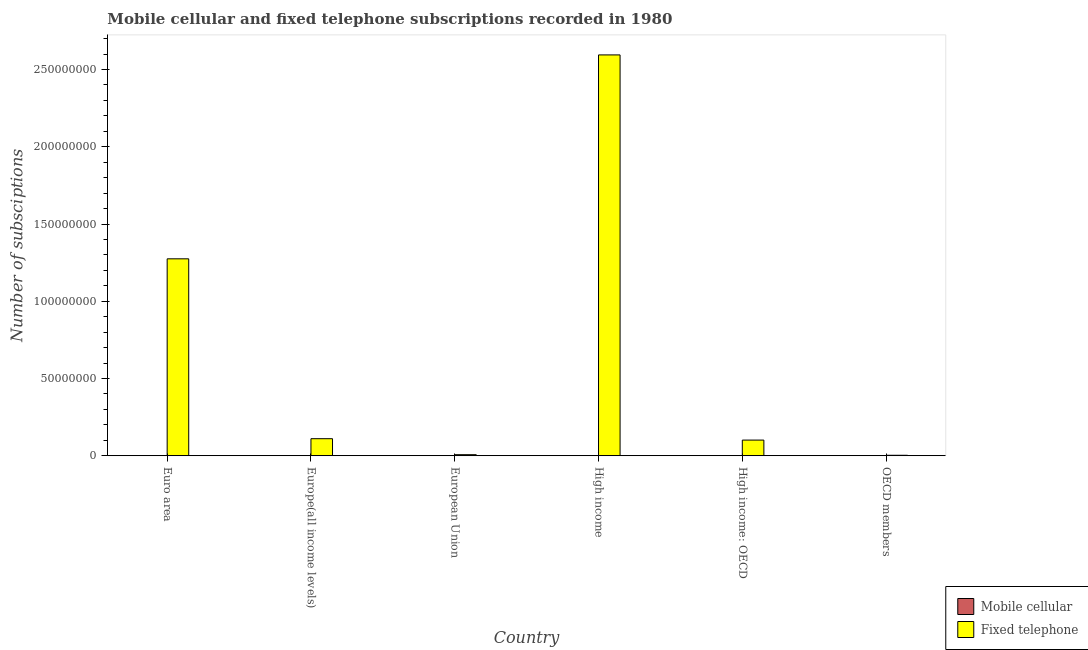How many different coloured bars are there?
Make the answer very short. 2. Are the number of bars on each tick of the X-axis equal?
Keep it short and to the point. Yes. How many bars are there on the 2nd tick from the left?
Your answer should be compact. 2. How many bars are there on the 1st tick from the right?
Provide a succinct answer. 2. What is the label of the 5th group of bars from the left?
Offer a very short reply. High income: OECD. In how many cases, is the number of bars for a given country not equal to the number of legend labels?
Your answer should be compact. 0. What is the number of mobile cellular subscriptions in Europe(all income levels)?
Offer a terse response. 2.35e+04. Across all countries, what is the maximum number of fixed telephone subscriptions?
Your answer should be very brief. 2.59e+08. Across all countries, what is the minimum number of mobile cellular subscriptions?
Offer a very short reply. 2.35e+04. What is the total number of fixed telephone subscriptions in the graph?
Your answer should be very brief. 4.09e+08. What is the difference between the number of fixed telephone subscriptions in European Union and that in High income: OECD?
Keep it short and to the point. -9.45e+06. What is the difference between the number of fixed telephone subscriptions in Euro area and the number of mobile cellular subscriptions in OECD members?
Your answer should be compact. 1.27e+08. What is the average number of fixed telephone subscriptions per country?
Your answer should be compact. 6.82e+07. What is the difference between the number of fixed telephone subscriptions and number of mobile cellular subscriptions in European Union?
Your response must be concise. 6.60e+05. Is the number of fixed telephone subscriptions in European Union less than that in High income: OECD?
Your answer should be compact. Yes. Is the difference between the number of fixed telephone subscriptions in European Union and OECD members greater than the difference between the number of mobile cellular subscriptions in European Union and OECD members?
Ensure brevity in your answer.  Yes. What is the difference between the highest and the second highest number of fixed telephone subscriptions?
Provide a succinct answer. 1.32e+08. What is the difference between the highest and the lowest number of mobile cellular subscriptions?
Your response must be concise. 0. In how many countries, is the number of mobile cellular subscriptions greater than the average number of mobile cellular subscriptions taken over all countries?
Provide a succinct answer. 0. What does the 1st bar from the left in High income: OECD represents?
Your answer should be compact. Mobile cellular. What does the 1st bar from the right in High income: OECD represents?
Your answer should be very brief. Fixed telephone. How many bars are there?
Your answer should be compact. 12. Are all the bars in the graph horizontal?
Provide a short and direct response. No. What is the difference between two consecutive major ticks on the Y-axis?
Offer a very short reply. 5.00e+07. Does the graph contain any zero values?
Provide a succinct answer. No. Does the graph contain grids?
Provide a short and direct response. No. Where does the legend appear in the graph?
Make the answer very short. Bottom right. How many legend labels are there?
Offer a terse response. 2. How are the legend labels stacked?
Offer a terse response. Vertical. What is the title of the graph?
Make the answer very short. Mobile cellular and fixed telephone subscriptions recorded in 1980. What is the label or title of the Y-axis?
Provide a succinct answer. Number of subsciptions. What is the Number of subsciptions of Mobile cellular in Euro area?
Give a very brief answer. 2.35e+04. What is the Number of subsciptions of Fixed telephone in Euro area?
Provide a succinct answer. 1.27e+08. What is the Number of subsciptions of Mobile cellular in Europe(all income levels)?
Offer a terse response. 2.35e+04. What is the Number of subsciptions of Fixed telephone in Europe(all income levels)?
Make the answer very short. 1.10e+07. What is the Number of subsciptions of Mobile cellular in European Union?
Your answer should be compact. 2.35e+04. What is the Number of subsciptions of Fixed telephone in European Union?
Keep it short and to the point. 6.83e+05. What is the Number of subsciptions of Mobile cellular in High income?
Your response must be concise. 2.35e+04. What is the Number of subsciptions of Fixed telephone in High income?
Offer a very short reply. 2.59e+08. What is the Number of subsciptions in Mobile cellular in High income: OECD?
Your answer should be very brief. 2.35e+04. What is the Number of subsciptions in Fixed telephone in High income: OECD?
Offer a very short reply. 1.01e+07. What is the Number of subsciptions of Mobile cellular in OECD members?
Ensure brevity in your answer.  2.35e+04. What is the Number of subsciptions of Fixed telephone in OECD members?
Give a very brief answer. 2.97e+05. Across all countries, what is the maximum Number of subsciptions in Mobile cellular?
Provide a short and direct response. 2.35e+04. Across all countries, what is the maximum Number of subsciptions in Fixed telephone?
Give a very brief answer. 2.59e+08. Across all countries, what is the minimum Number of subsciptions of Mobile cellular?
Your response must be concise. 2.35e+04. Across all countries, what is the minimum Number of subsciptions of Fixed telephone?
Ensure brevity in your answer.  2.97e+05. What is the total Number of subsciptions in Mobile cellular in the graph?
Your response must be concise. 1.41e+05. What is the total Number of subsciptions of Fixed telephone in the graph?
Offer a very short reply. 4.09e+08. What is the difference between the Number of subsciptions of Fixed telephone in Euro area and that in Europe(all income levels)?
Your answer should be very brief. 1.16e+08. What is the difference between the Number of subsciptions in Mobile cellular in Euro area and that in European Union?
Provide a short and direct response. 0. What is the difference between the Number of subsciptions of Fixed telephone in Euro area and that in European Union?
Make the answer very short. 1.27e+08. What is the difference between the Number of subsciptions of Fixed telephone in Euro area and that in High income?
Give a very brief answer. -1.32e+08. What is the difference between the Number of subsciptions of Mobile cellular in Euro area and that in High income: OECD?
Provide a short and direct response. 0. What is the difference between the Number of subsciptions of Fixed telephone in Euro area and that in High income: OECD?
Make the answer very short. 1.17e+08. What is the difference between the Number of subsciptions in Mobile cellular in Euro area and that in OECD members?
Ensure brevity in your answer.  0. What is the difference between the Number of subsciptions of Fixed telephone in Euro area and that in OECD members?
Offer a terse response. 1.27e+08. What is the difference between the Number of subsciptions of Mobile cellular in Europe(all income levels) and that in European Union?
Your answer should be compact. 0. What is the difference between the Number of subsciptions in Fixed telephone in Europe(all income levels) and that in European Union?
Give a very brief answer. 1.03e+07. What is the difference between the Number of subsciptions of Mobile cellular in Europe(all income levels) and that in High income?
Your answer should be very brief. 0. What is the difference between the Number of subsciptions of Fixed telephone in Europe(all income levels) and that in High income?
Provide a succinct answer. -2.48e+08. What is the difference between the Number of subsciptions in Mobile cellular in Europe(all income levels) and that in High income: OECD?
Make the answer very short. 0. What is the difference between the Number of subsciptions in Fixed telephone in Europe(all income levels) and that in High income: OECD?
Make the answer very short. 8.98e+05. What is the difference between the Number of subsciptions of Fixed telephone in Europe(all income levels) and that in OECD members?
Ensure brevity in your answer.  1.07e+07. What is the difference between the Number of subsciptions of Fixed telephone in European Union and that in High income?
Ensure brevity in your answer.  -2.59e+08. What is the difference between the Number of subsciptions in Mobile cellular in European Union and that in High income: OECD?
Keep it short and to the point. 0. What is the difference between the Number of subsciptions of Fixed telephone in European Union and that in High income: OECD?
Provide a short and direct response. -9.45e+06. What is the difference between the Number of subsciptions of Mobile cellular in European Union and that in OECD members?
Offer a terse response. 0. What is the difference between the Number of subsciptions in Fixed telephone in European Union and that in OECD members?
Your answer should be compact. 3.86e+05. What is the difference between the Number of subsciptions of Mobile cellular in High income and that in High income: OECD?
Offer a very short reply. 0. What is the difference between the Number of subsciptions in Fixed telephone in High income and that in High income: OECD?
Offer a very short reply. 2.49e+08. What is the difference between the Number of subsciptions in Fixed telephone in High income and that in OECD members?
Keep it short and to the point. 2.59e+08. What is the difference between the Number of subsciptions in Fixed telephone in High income: OECD and that in OECD members?
Keep it short and to the point. 9.83e+06. What is the difference between the Number of subsciptions in Mobile cellular in Euro area and the Number of subsciptions in Fixed telephone in Europe(all income levels)?
Your answer should be very brief. -1.10e+07. What is the difference between the Number of subsciptions in Mobile cellular in Euro area and the Number of subsciptions in Fixed telephone in European Union?
Your answer should be very brief. -6.60e+05. What is the difference between the Number of subsciptions in Mobile cellular in Euro area and the Number of subsciptions in Fixed telephone in High income?
Your response must be concise. -2.59e+08. What is the difference between the Number of subsciptions in Mobile cellular in Euro area and the Number of subsciptions in Fixed telephone in High income: OECD?
Keep it short and to the point. -1.01e+07. What is the difference between the Number of subsciptions in Mobile cellular in Euro area and the Number of subsciptions in Fixed telephone in OECD members?
Offer a terse response. -2.74e+05. What is the difference between the Number of subsciptions of Mobile cellular in Europe(all income levels) and the Number of subsciptions of Fixed telephone in European Union?
Your answer should be very brief. -6.60e+05. What is the difference between the Number of subsciptions of Mobile cellular in Europe(all income levels) and the Number of subsciptions of Fixed telephone in High income?
Provide a short and direct response. -2.59e+08. What is the difference between the Number of subsciptions of Mobile cellular in Europe(all income levels) and the Number of subsciptions of Fixed telephone in High income: OECD?
Ensure brevity in your answer.  -1.01e+07. What is the difference between the Number of subsciptions in Mobile cellular in Europe(all income levels) and the Number of subsciptions in Fixed telephone in OECD members?
Give a very brief answer. -2.74e+05. What is the difference between the Number of subsciptions of Mobile cellular in European Union and the Number of subsciptions of Fixed telephone in High income?
Your answer should be compact. -2.59e+08. What is the difference between the Number of subsciptions in Mobile cellular in European Union and the Number of subsciptions in Fixed telephone in High income: OECD?
Ensure brevity in your answer.  -1.01e+07. What is the difference between the Number of subsciptions of Mobile cellular in European Union and the Number of subsciptions of Fixed telephone in OECD members?
Provide a succinct answer. -2.74e+05. What is the difference between the Number of subsciptions in Mobile cellular in High income and the Number of subsciptions in Fixed telephone in High income: OECD?
Offer a terse response. -1.01e+07. What is the difference between the Number of subsciptions of Mobile cellular in High income and the Number of subsciptions of Fixed telephone in OECD members?
Your answer should be very brief. -2.74e+05. What is the difference between the Number of subsciptions of Mobile cellular in High income: OECD and the Number of subsciptions of Fixed telephone in OECD members?
Provide a short and direct response. -2.74e+05. What is the average Number of subsciptions of Mobile cellular per country?
Make the answer very short. 2.35e+04. What is the average Number of subsciptions in Fixed telephone per country?
Your response must be concise. 6.82e+07. What is the difference between the Number of subsciptions in Mobile cellular and Number of subsciptions in Fixed telephone in Euro area?
Provide a short and direct response. -1.27e+08. What is the difference between the Number of subsciptions of Mobile cellular and Number of subsciptions of Fixed telephone in Europe(all income levels)?
Provide a short and direct response. -1.10e+07. What is the difference between the Number of subsciptions in Mobile cellular and Number of subsciptions in Fixed telephone in European Union?
Your response must be concise. -6.60e+05. What is the difference between the Number of subsciptions in Mobile cellular and Number of subsciptions in Fixed telephone in High income?
Provide a short and direct response. -2.59e+08. What is the difference between the Number of subsciptions in Mobile cellular and Number of subsciptions in Fixed telephone in High income: OECD?
Provide a short and direct response. -1.01e+07. What is the difference between the Number of subsciptions of Mobile cellular and Number of subsciptions of Fixed telephone in OECD members?
Ensure brevity in your answer.  -2.74e+05. What is the ratio of the Number of subsciptions of Fixed telephone in Euro area to that in Europe(all income levels)?
Provide a succinct answer. 11.56. What is the ratio of the Number of subsciptions in Mobile cellular in Euro area to that in European Union?
Make the answer very short. 1. What is the ratio of the Number of subsciptions in Fixed telephone in Euro area to that in European Union?
Give a very brief answer. 186.63. What is the ratio of the Number of subsciptions of Mobile cellular in Euro area to that in High income?
Offer a terse response. 1. What is the ratio of the Number of subsciptions of Fixed telephone in Euro area to that in High income?
Ensure brevity in your answer.  0.49. What is the ratio of the Number of subsciptions of Fixed telephone in Euro area to that in High income: OECD?
Provide a succinct answer. 12.59. What is the ratio of the Number of subsciptions in Mobile cellular in Euro area to that in OECD members?
Your response must be concise. 1. What is the ratio of the Number of subsciptions in Fixed telephone in Euro area to that in OECD members?
Provide a succinct answer. 428.93. What is the ratio of the Number of subsciptions of Fixed telephone in Europe(all income levels) to that in European Union?
Your answer should be compact. 16.14. What is the ratio of the Number of subsciptions in Mobile cellular in Europe(all income levels) to that in High income?
Offer a very short reply. 1. What is the ratio of the Number of subsciptions of Fixed telephone in Europe(all income levels) to that in High income?
Keep it short and to the point. 0.04. What is the ratio of the Number of subsciptions of Fixed telephone in Europe(all income levels) to that in High income: OECD?
Your answer should be compact. 1.09. What is the ratio of the Number of subsciptions of Mobile cellular in Europe(all income levels) to that in OECD members?
Your answer should be very brief. 1. What is the ratio of the Number of subsciptions in Fixed telephone in Europe(all income levels) to that in OECD members?
Your answer should be compact. 37.1. What is the ratio of the Number of subsciptions in Mobile cellular in European Union to that in High income?
Provide a succinct answer. 1. What is the ratio of the Number of subsciptions of Fixed telephone in European Union to that in High income?
Provide a short and direct response. 0. What is the ratio of the Number of subsciptions of Fixed telephone in European Union to that in High income: OECD?
Offer a very short reply. 0.07. What is the ratio of the Number of subsciptions of Fixed telephone in European Union to that in OECD members?
Your answer should be compact. 2.3. What is the ratio of the Number of subsciptions in Fixed telephone in High income to that in High income: OECD?
Offer a very short reply. 25.62. What is the ratio of the Number of subsciptions in Fixed telephone in High income to that in OECD members?
Your response must be concise. 873.07. What is the ratio of the Number of subsciptions in Mobile cellular in High income: OECD to that in OECD members?
Offer a terse response. 1. What is the ratio of the Number of subsciptions in Fixed telephone in High income: OECD to that in OECD members?
Provide a succinct answer. 34.08. What is the difference between the highest and the second highest Number of subsciptions of Mobile cellular?
Your answer should be compact. 0. What is the difference between the highest and the second highest Number of subsciptions of Fixed telephone?
Offer a terse response. 1.32e+08. What is the difference between the highest and the lowest Number of subsciptions of Mobile cellular?
Give a very brief answer. 0. What is the difference between the highest and the lowest Number of subsciptions in Fixed telephone?
Make the answer very short. 2.59e+08. 